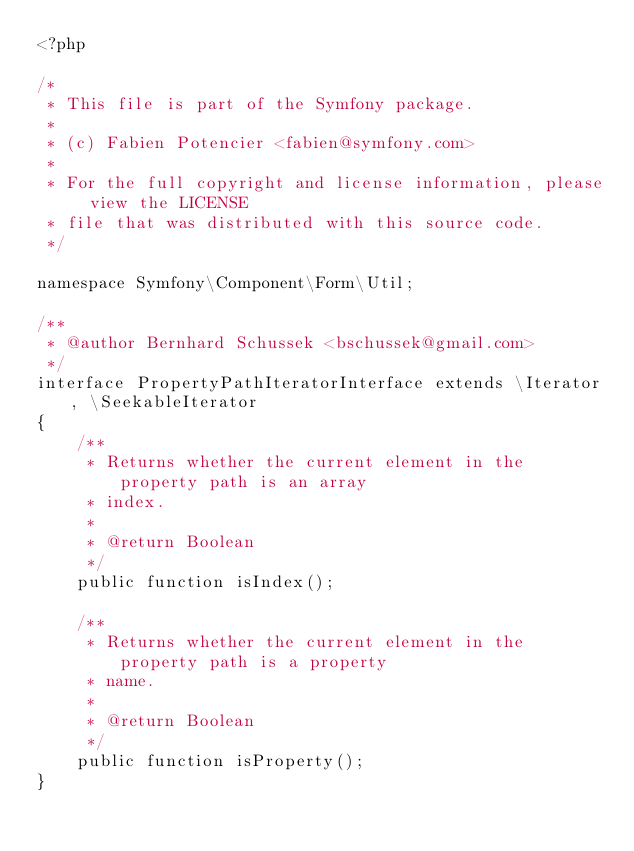<code> <loc_0><loc_0><loc_500><loc_500><_PHP_><?php

/*
 * This file is part of the Symfony package.
 *
 * (c) Fabien Potencier <fabien@symfony.com>
 *
 * For the full copyright and license information, please view the LICENSE
 * file that was distributed with this source code.
 */

namespace Symfony\Component\Form\Util;

/**
 * @author Bernhard Schussek <bschussek@gmail.com>
 */
interface PropertyPathIteratorInterface extends \Iterator, \SeekableIterator
{
    /**
     * Returns whether the current element in the property path is an array
     * index.
     *
     * @return Boolean
     */
    public function isIndex();

    /**
     * Returns whether the current element in the property path is a property
     * name.
     *
     * @return Boolean
     */
    public function isProperty();
}
</code> 